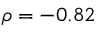Convert formula to latex. <formula><loc_0><loc_0><loc_500><loc_500>\rho = - 0 . 8 2</formula> 